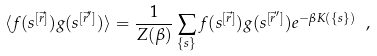Convert formula to latex. <formula><loc_0><loc_0><loc_500><loc_500>\langle f ( s ^ { [ \vec { r } ] } ) g ( s ^ { [ \vec { r } ^ { \prime } ] } ) \rangle = \frac { 1 } { Z ( \beta ) } \sum _ { \{ s \} } f ( s ^ { [ \vec { r } ] } ) g ( s ^ { [ \vec { r } ^ { \prime } ] } ) e ^ { - \beta K ( \{ s \} ) } \ ,</formula> 